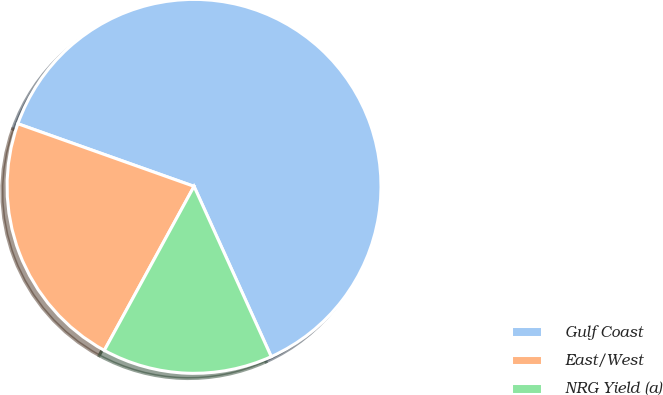Convert chart. <chart><loc_0><loc_0><loc_500><loc_500><pie_chart><fcel>Gulf Coast<fcel>East/West<fcel>NRG Yield (a)<nl><fcel>62.79%<fcel>22.47%<fcel>14.74%<nl></chart> 